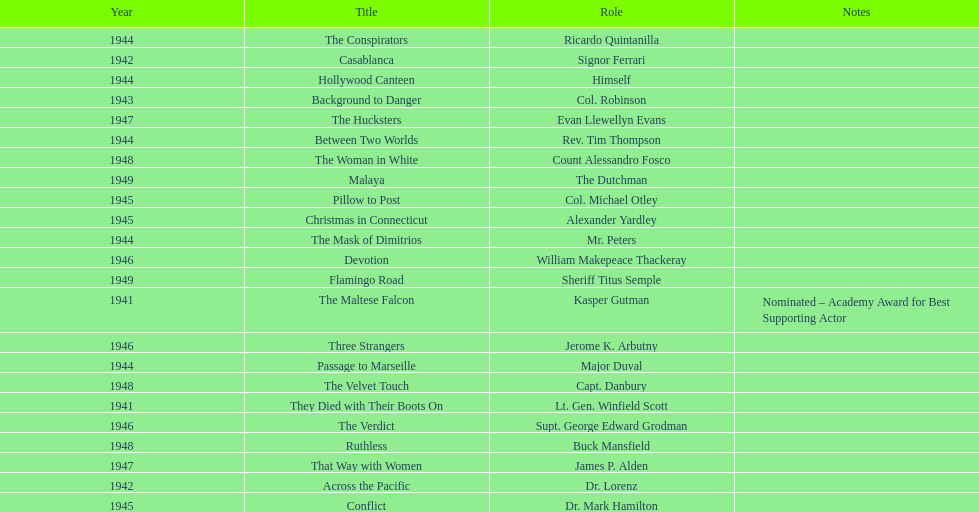What movies did greenstreet act for in 1946? Three Strangers, Devotion, The Verdict. 